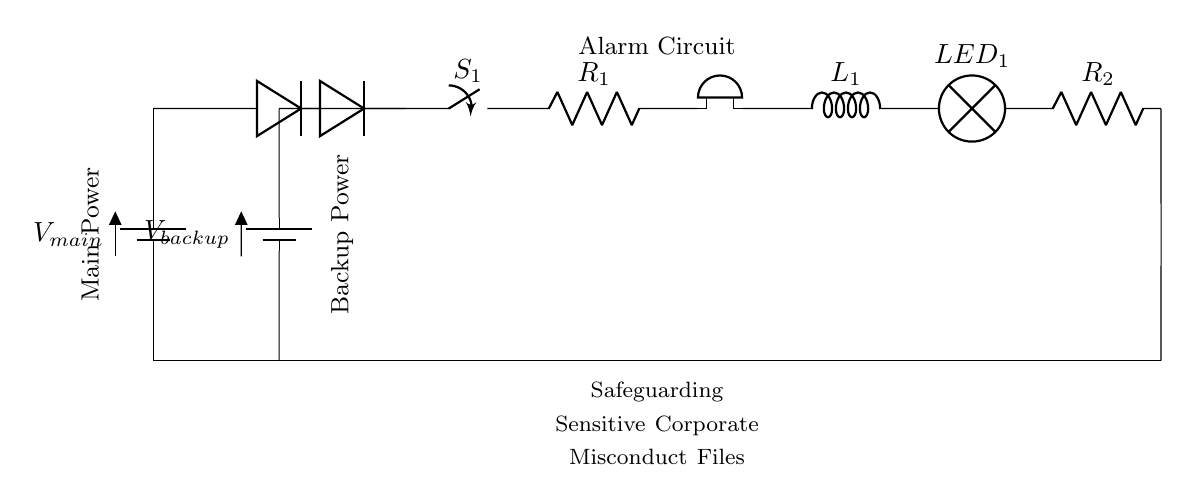What type of batteries are used in this circuit? There are two types of batteries depicted: the main power supply and the backup battery, both labeled as battery components in the circuit diagram.
Answer: Main and backup What is the function of the diodes in this circuit? The diodes allow current to flow in one direction only, preventing reverse current that could damage the components and ensuring that power is sourced from the higher voltage battery, either main or backup.
Answer: Power isolation What component indicates an alarm condition? The buzzer is the component specifically designed to produce an alarm sound when activated by the circuit, alerting users to a potential issue.
Answer: Buzzer What happens when switch S1 is opened? When switch S1 is opened, the circuit is interrupted, stopping the current flow to the downstream components, which prevents the alarm system from operating.
Answer: Circuit interruption How are the main and backup power sources connected to the alarm system? Both the main and backup batteries are connected through diodes to a common point (junction), allowing the alarm system to use power from whichever source is active, thus ensuring continuous operation.
Answer: Parallel configuration What role does the LED play in the circuit? The LED serves as a visual indicator that the alarm system is powered on and functioning, often illuminating in response to an alarm condition or when power is supplied.
Answer: Visual indicator 